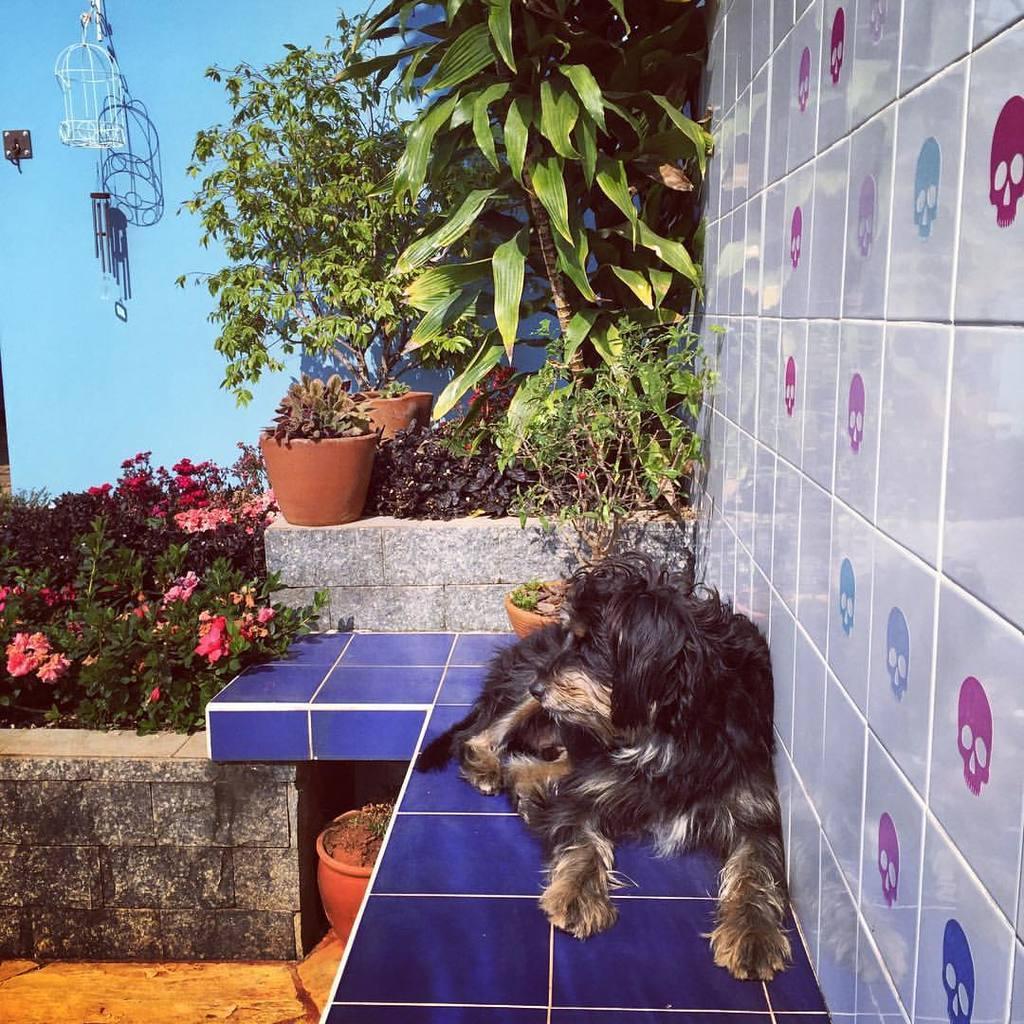Can you describe this image briefly? In the picture I can see a dog is sitting. In the background I can see plant pots, flowers, plants, a wall and some other objects. 